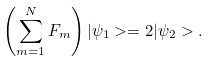<formula> <loc_0><loc_0><loc_500><loc_500>\left ( \sum _ { m = 1 } ^ { N } F _ { m } \right ) | \psi _ { 1 } > = 2 | \psi _ { 2 } > .</formula> 